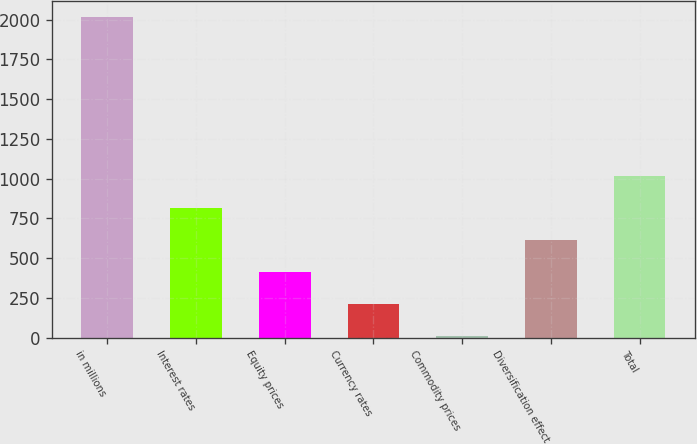Convert chart to OTSL. <chart><loc_0><loc_0><loc_500><loc_500><bar_chart><fcel>in millions<fcel>Interest rates<fcel>Equity prices<fcel>Currency rates<fcel>Commodity prices<fcel>Diversification effect<fcel>Total<nl><fcel>2018<fcel>813.8<fcel>412.4<fcel>211.7<fcel>11<fcel>613.1<fcel>1014.5<nl></chart> 